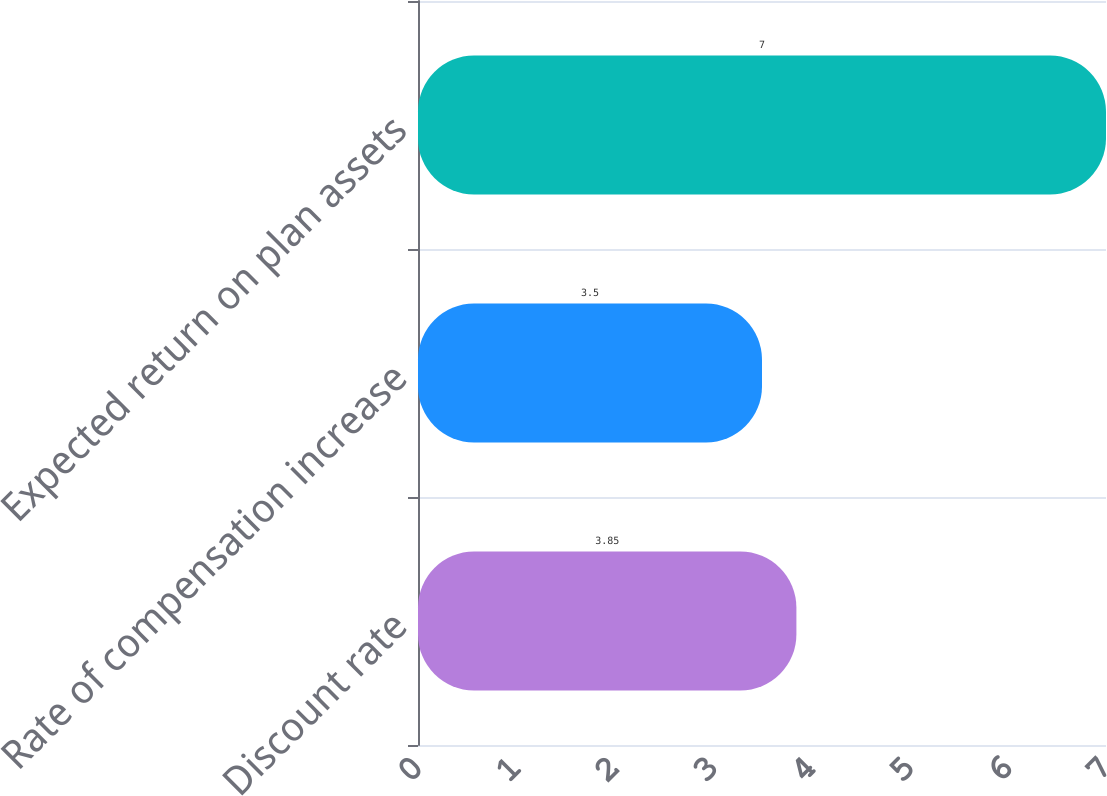Convert chart to OTSL. <chart><loc_0><loc_0><loc_500><loc_500><bar_chart><fcel>Discount rate<fcel>Rate of compensation increase<fcel>Expected return on plan assets<nl><fcel>3.85<fcel>3.5<fcel>7<nl></chart> 